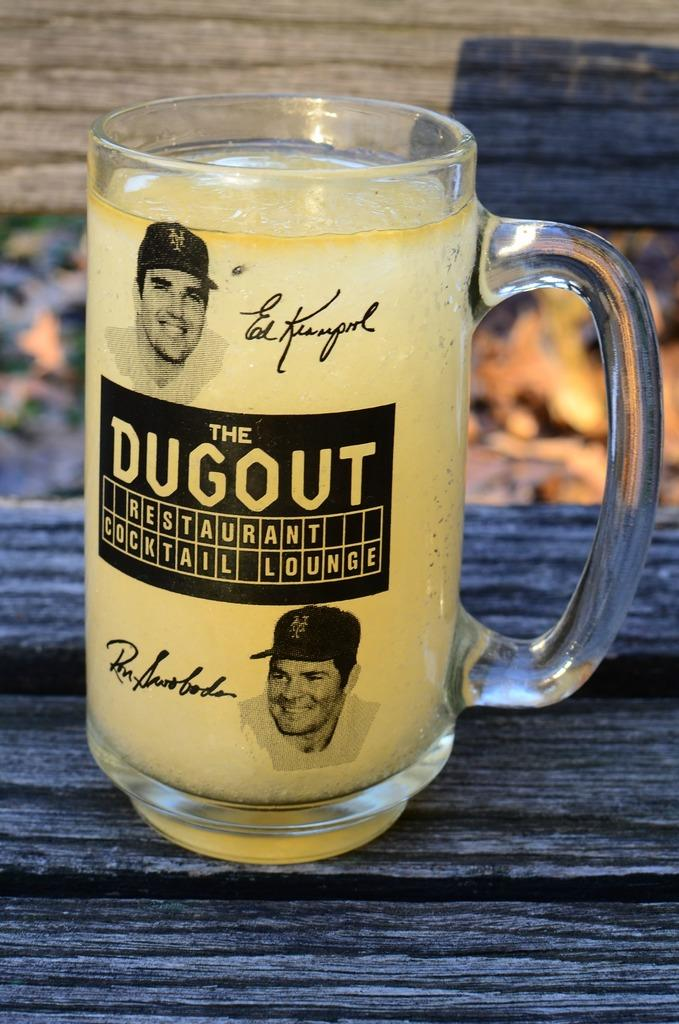What piece of furniture is visible in the image? There is a table in the image. What object is placed on the table? A glass is present on the table. What is inside the glass? The glass contains some liquid. What is written on the glass? The glass has "The dugout" printed on it. What can be seen in the background of the image? There is a brown color wall in the background of the image. How many seeds can be seen on the leaf in the image? There are no seeds or leaves present in the image; it features a table, a glass, and a wall. 